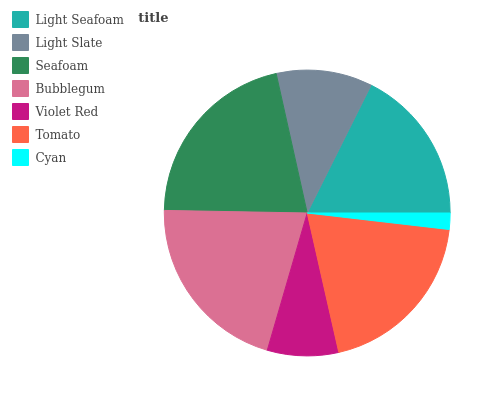Is Cyan the minimum?
Answer yes or no. Yes. Is Seafoam the maximum?
Answer yes or no. Yes. Is Light Slate the minimum?
Answer yes or no. No. Is Light Slate the maximum?
Answer yes or no. No. Is Light Seafoam greater than Light Slate?
Answer yes or no. Yes. Is Light Slate less than Light Seafoam?
Answer yes or no. Yes. Is Light Slate greater than Light Seafoam?
Answer yes or no. No. Is Light Seafoam less than Light Slate?
Answer yes or no. No. Is Light Seafoam the high median?
Answer yes or no. Yes. Is Light Seafoam the low median?
Answer yes or no. Yes. Is Bubblegum the high median?
Answer yes or no. No. Is Light Slate the low median?
Answer yes or no. No. 